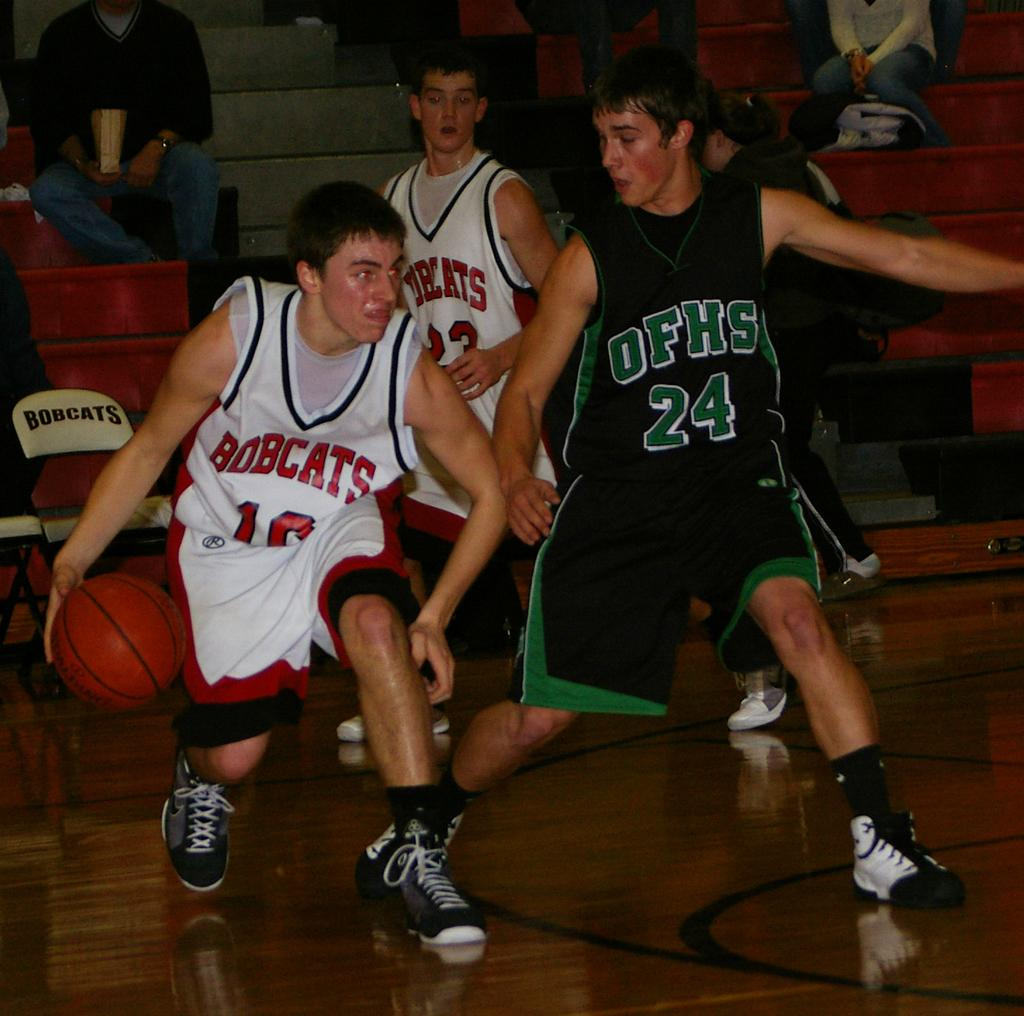<image>
Present a compact description of the photo's key features. A basketball game featuring the Bobcats playing another team with OFHS on their uniform. 